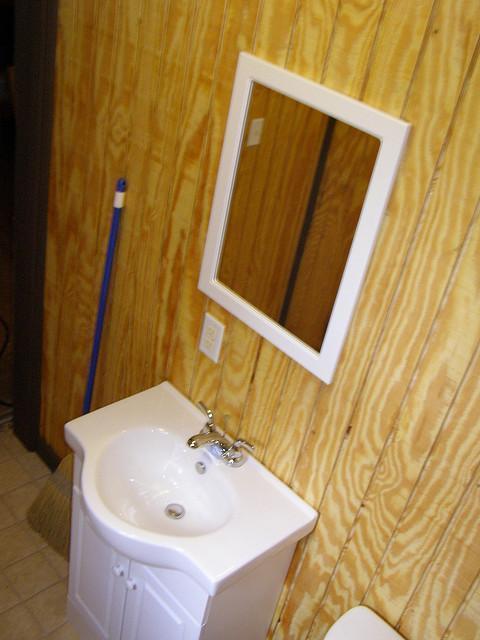How many people are on the water?
Give a very brief answer. 0. 